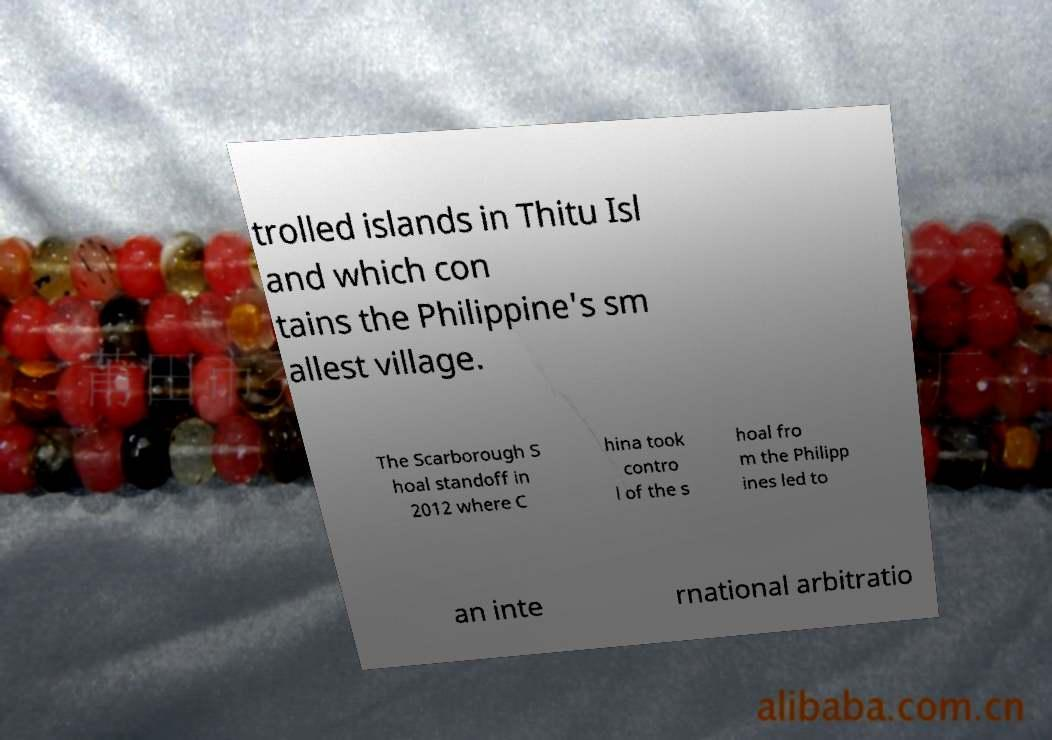I need the written content from this picture converted into text. Can you do that? trolled islands in Thitu Isl and which con tains the Philippine's sm allest village. The Scarborough S hoal standoff in 2012 where C hina took contro l of the s hoal fro m the Philipp ines led to an inte rnational arbitratio 